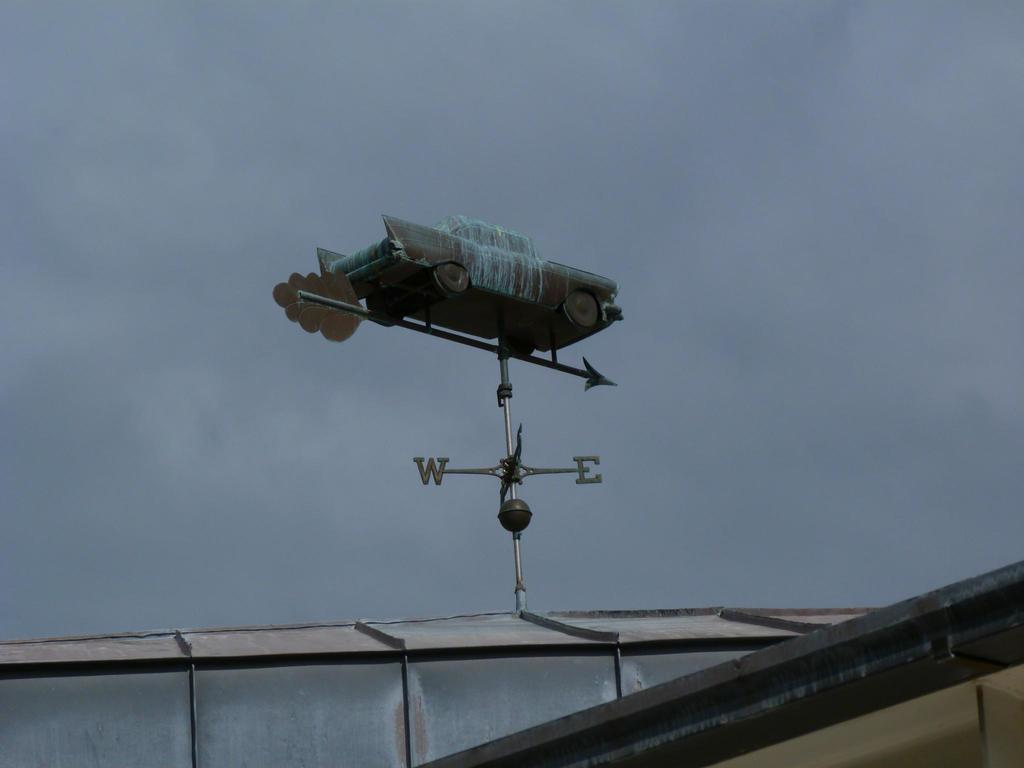Provide a one-sentence caption for the provided image. An ersatz weather vane with W and E directionals has a car on top. 